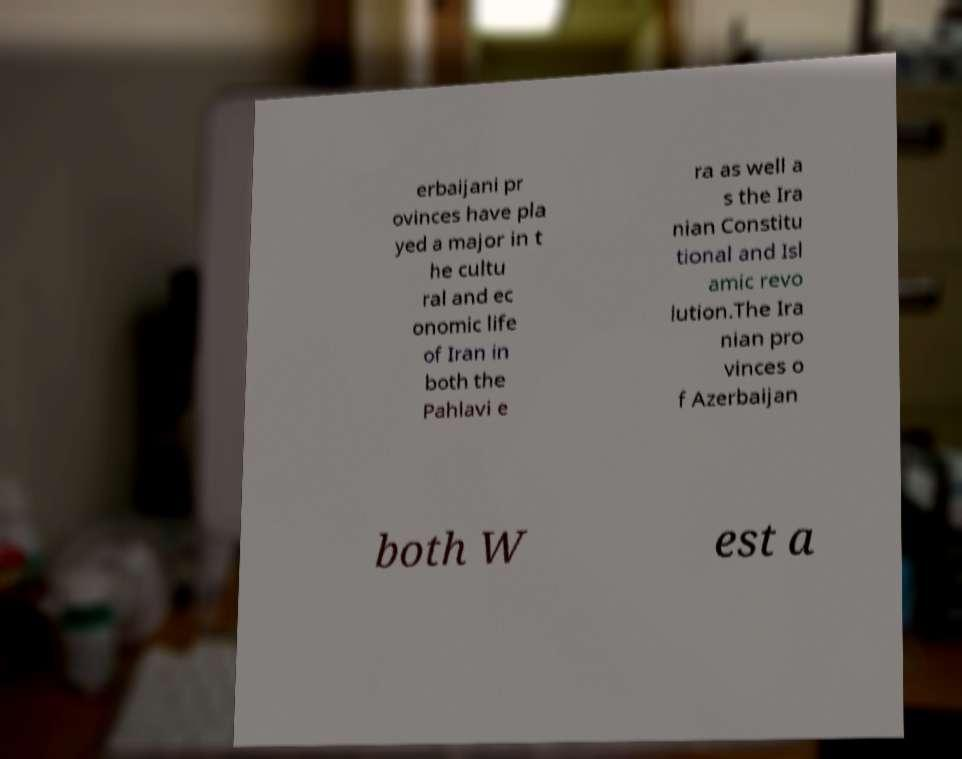Could you extract and type out the text from this image? erbaijani pr ovinces have pla yed a major in t he cultu ral and ec onomic life of Iran in both the Pahlavi e ra as well a s the Ira nian Constitu tional and Isl amic revo lution.The Ira nian pro vinces o f Azerbaijan both W est a 